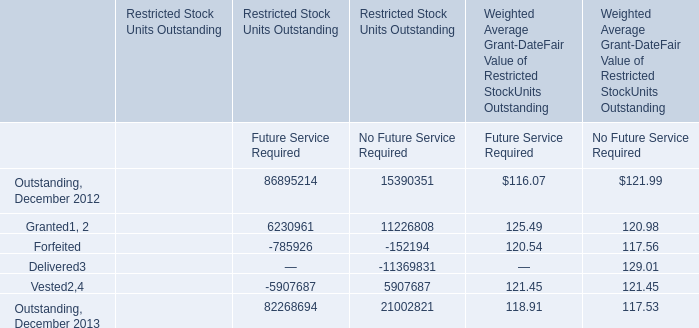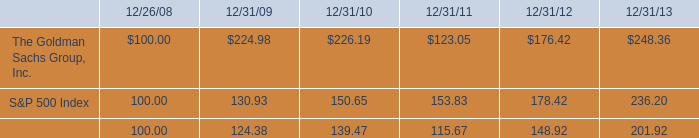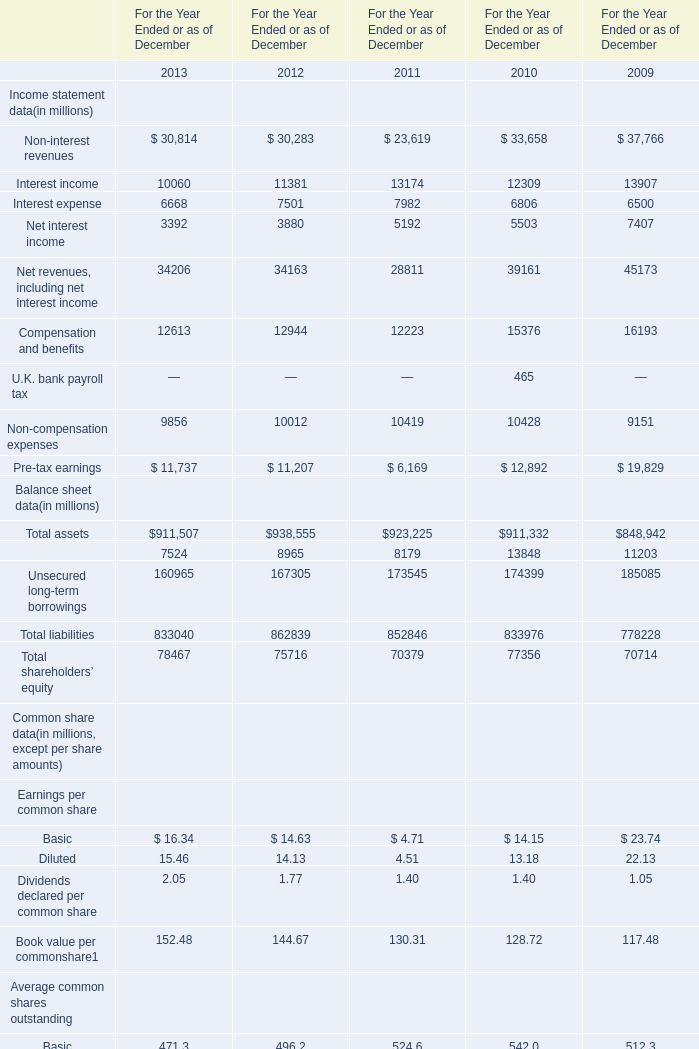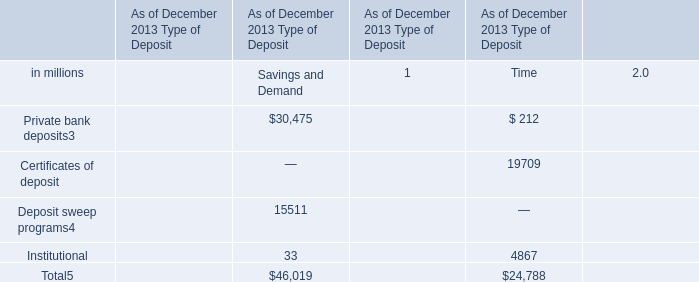What is the total value of the Total assets, the Unsecured long-term borrowings and the Total liabilities in 2011? (in million) 
Computations: ((923225 + 173545) + 852846)
Answer: 1949616.0. 